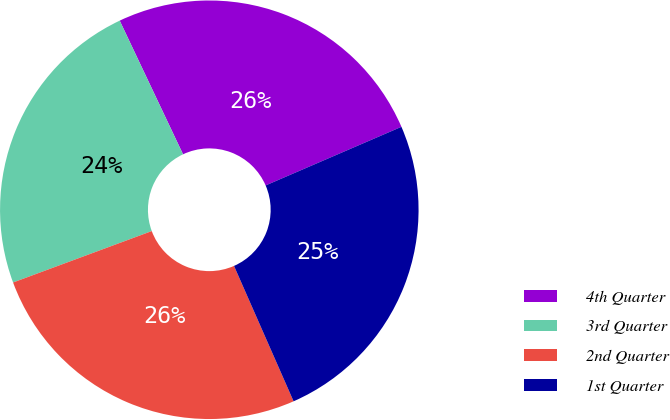Convert chart. <chart><loc_0><loc_0><loc_500><loc_500><pie_chart><fcel>4th Quarter<fcel>3rd Quarter<fcel>2nd Quarter<fcel>1st Quarter<nl><fcel>25.56%<fcel>23.61%<fcel>25.95%<fcel>24.89%<nl></chart> 